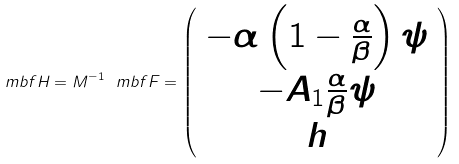<formula> <loc_0><loc_0><loc_500><loc_500>\ m b f H = M ^ { - 1 } \ m b f F = \left ( \begin{array} { c } - \alpha \left ( 1 - \frac { \alpha } { \beta } \right ) \psi \\ - A _ { 1 } \frac { \alpha } { \beta } \psi \\ h \\ \end{array} \right )</formula> 